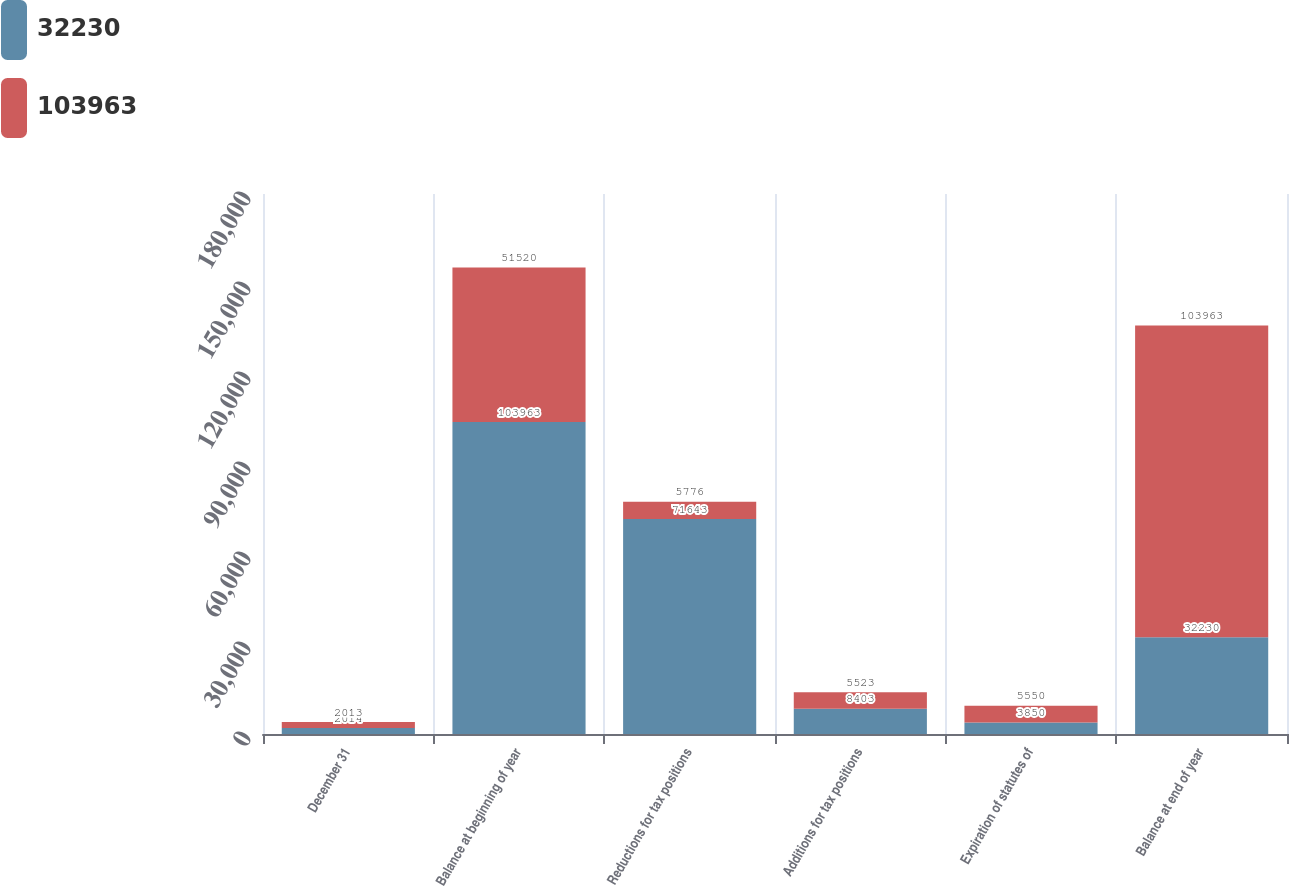Convert chart. <chart><loc_0><loc_0><loc_500><loc_500><stacked_bar_chart><ecel><fcel>December 31<fcel>Balance at beginning of year<fcel>Reductions for tax positions<fcel>Additions for tax positions<fcel>Expiration of statutes of<fcel>Balance at end of year<nl><fcel>32230<fcel>2014<fcel>103963<fcel>71643<fcel>8403<fcel>3850<fcel>32230<nl><fcel>103963<fcel>2013<fcel>51520<fcel>5776<fcel>5523<fcel>5550<fcel>103963<nl></chart> 